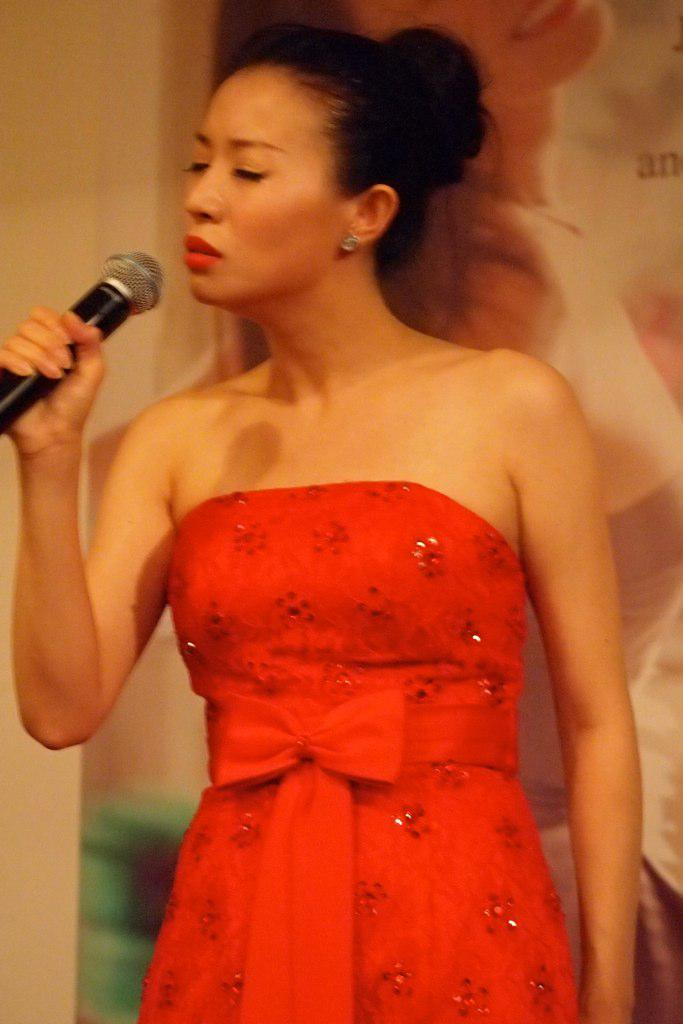Who is the main subject in the image? There is a lady in the image. Where is the lady positioned in the image? The lady is standing at the center of the image. What is the lady holding in her hand? The lady is holding a mic in her hand. What might the lady be doing with the mic? It appears that the lady is singing, as she is holding a mic. What type of juice is being squeezed in the image? There is no juice or squeezing activity present in the image. What type of competition is the lady participating in? There is no competition present in the image; the lady appears to be singing. 